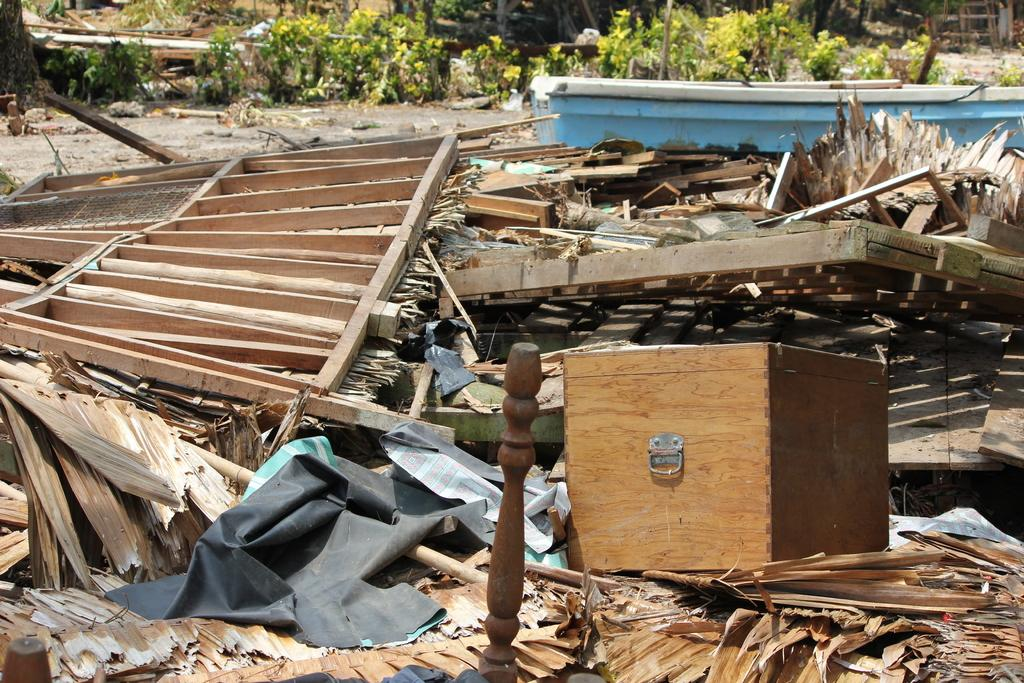What type of container is visible in the image? There is a wooden box in the image. What other wooden items can be seen in the image? There are wooden stands in the image. What natural elements are present in the image? There are logs, plants, and dry leaves in the image. What structural elements can be seen in the image? There are poles in the image. Are there any unidentified objects in the image? Yes, there are some unspecified objects in the image. What type of noise can be heard coming from the parcel in the image? There is no parcel present in the image, so it is not possible to determine what noise might be coming from it. 